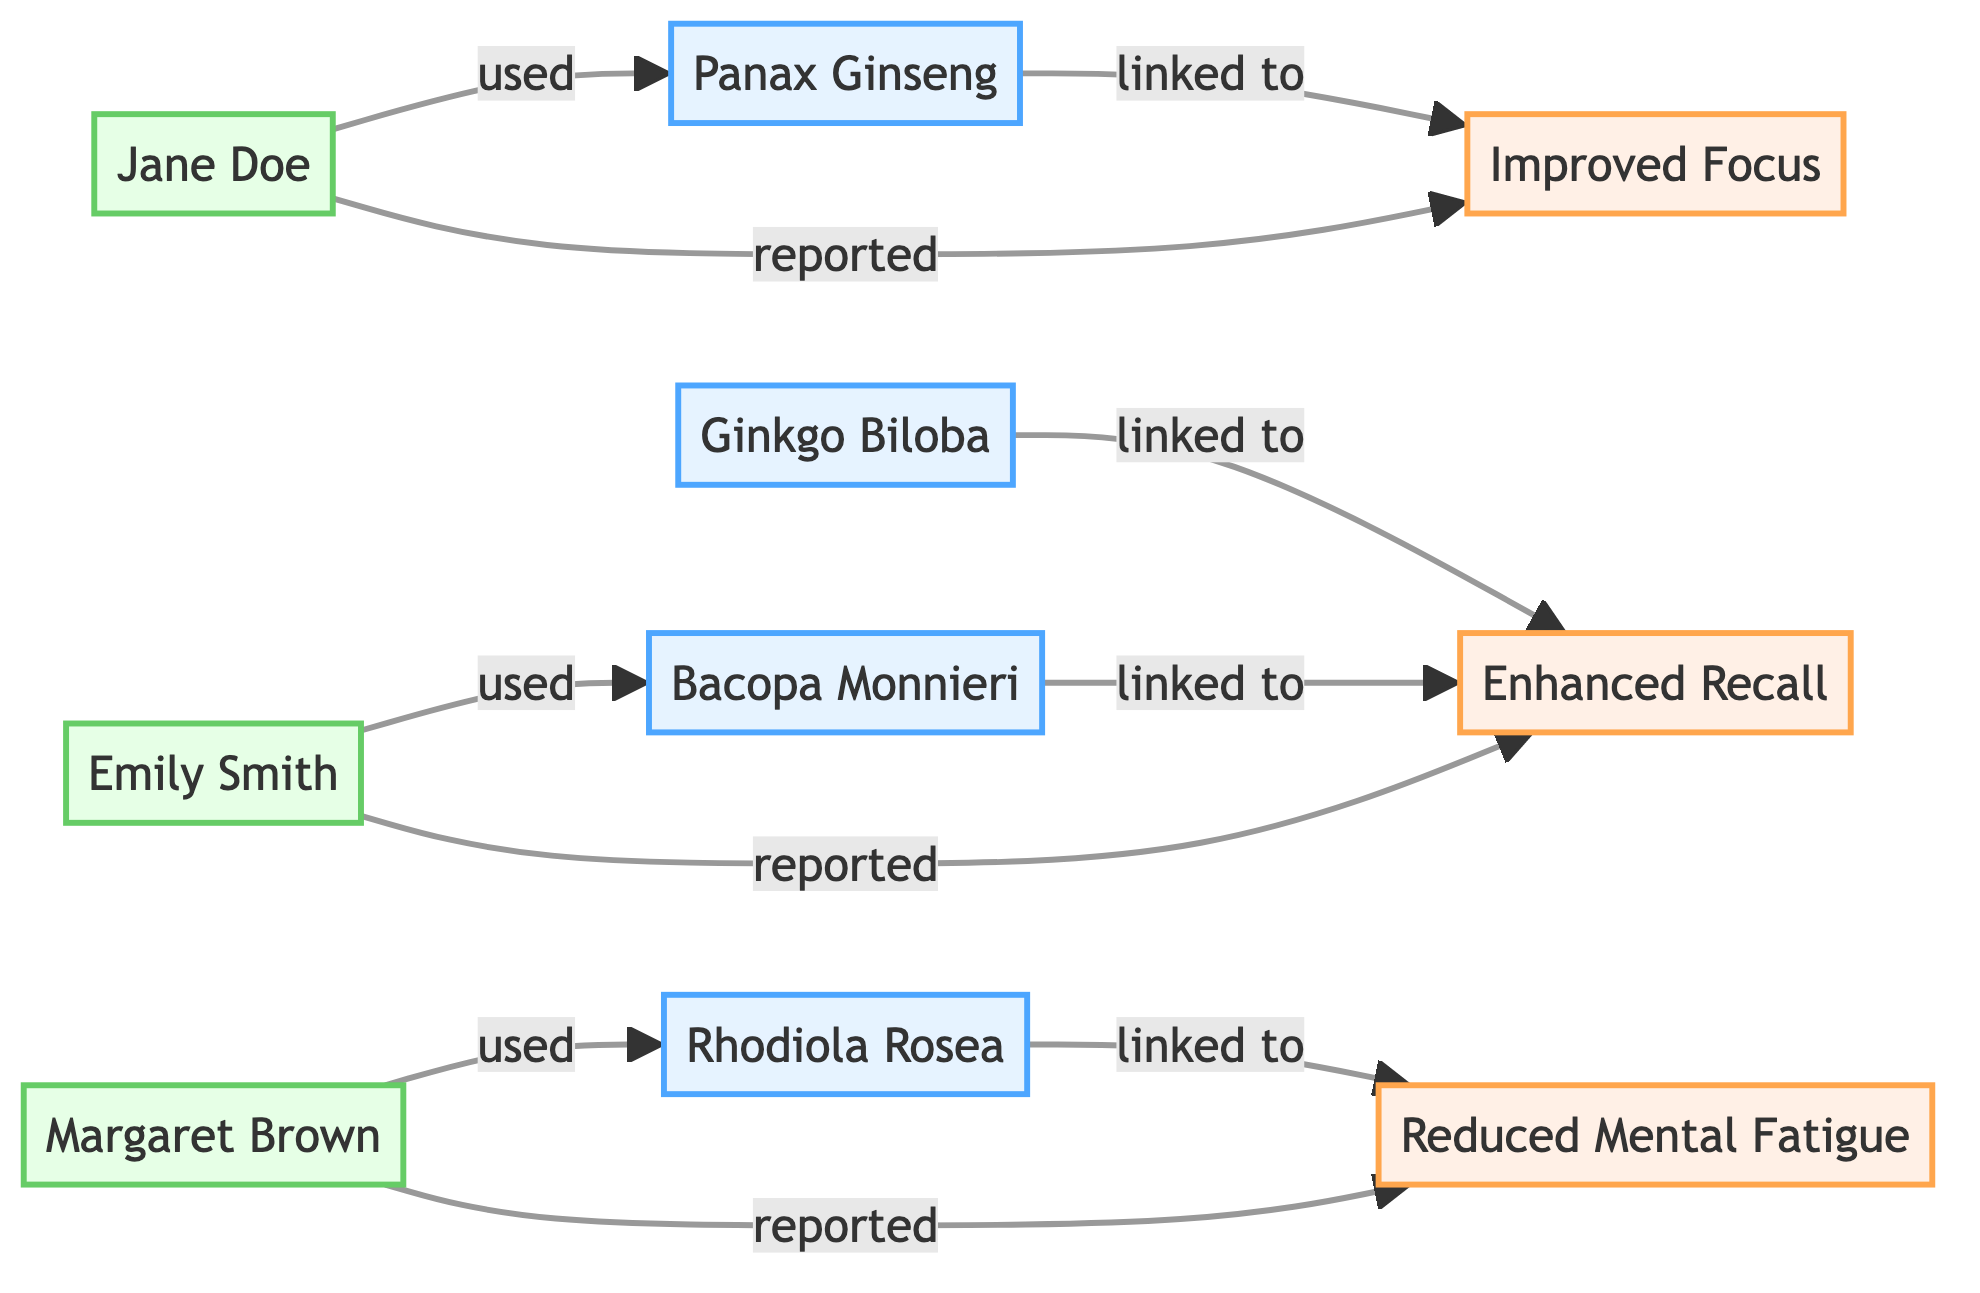What are the total number of herbal supplements represented? The diagram includes four herbal supplements: Ginkgo Biloba, Panax Ginseng, Bacopa Monnieri, and Rhodiola Rosea. Therefore, when counted, the total is four.
Answer: 4 Which herbal supplement is linked to Enhanced Recall? The diagram shows two herbal supplements linked to Enhanced Recall: Ginkgo Biloba and Bacopa Monnieri. Both have a direct connection to Enhanced Recall.
Answer: Ginkgo Biloba, Bacopa Monnieri Who reported Improved Focus? The diagram indicates that Jane Doe reported Improved Focus. She is the only reviewer connected directly to this effect.
Answer: Jane Doe Which reviewer used Bacopa Monnieri? According to the diagram, Emily Smith is the reviewer who used Bacopa Monnieri. She is connected to this herbal supplement through the "used" relationship.
Answer: Emily Smith What effect is linked to Rhodiola Rosea? The diagram shows that Rhodiola Rosea is linked to Reduced Mental Fatigue as the reported effect. This is the only effect associated with Rhodiola Rosea in the diagram.
Answer: Reduced Mental Fatigue How many reviewers reported effects in total? In the diagram, there are three reviewers: Jane Doe, Emily Smith, and Margaret Brown. Jane reported Improved Focus, Emily reported Enhanced Recall, and Margaret reported Reduced Mental Fatigue. Counting these reports, there are three.
Answer: 3 Which two herbal supplements are linked to the same reported effect? The diagram shows that both Ginkgo Biloba and Bacopa Monnieri are linked to Enhanced Recall. This indicates that these two supplements share the same reported effect.
Answer: Ginkgo Biloba, Bacopa Monnieri What type of node is Jane Doe? In the diagram, Jane Doe is categorized as a reviewer, as indicated by her classification and the connections she holds with the effects.
Answer: Reviewer 